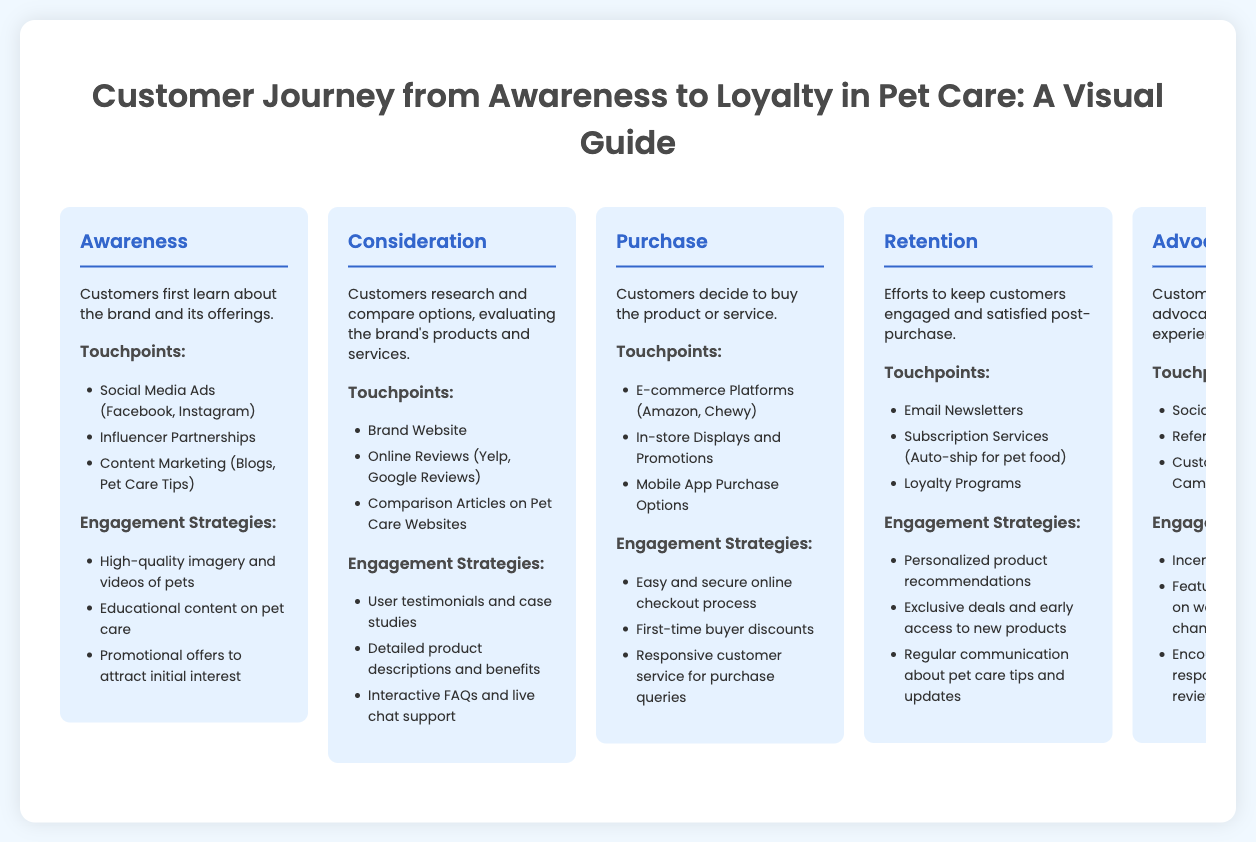What is the first phase of the customer journey? The first phase is where customers learn about the brand and its offerings.
Answer: Awareness What touchpoint is associated with the Consideration phase? The touchpoint is identified as a key element during the Consideration phase for researching options.
Answer: Brand Website What engagement strategy is emphasized in the Retention phase? The strategy that focuses on keeping customers engaged and satisfied post-purchase.
Answer: Personalized product recommendations How many phases are outlined in the customer journey? The phases listed show the progression from discovery to loyalty.
Answer: Five phases What type of programs are mentioned in the Advocacy phase? The programs encourage customers to spread positive experiences and support the brand.
Answer: Referral Programs Which social media platforms are highlighted in the Awareness phase? These platforms are utilized to advertise the brand and engage potential customers.
Answer: Facebook, Instagram What is the main goal of the Purchase phase? The goal is for customers to complete the acquisition of the product or service.
Answer: Buy the product What is a key touchpoint in the Retention phase? This touchpoint focuses on maintaining customer engagement after purchase.
Answer: Email Newsletters What strategy is meant for post-purchase communication? This strategy is intended to keep customers informed and engaged about new offerings.
Answer: Regular communication about pet care tips and updates 